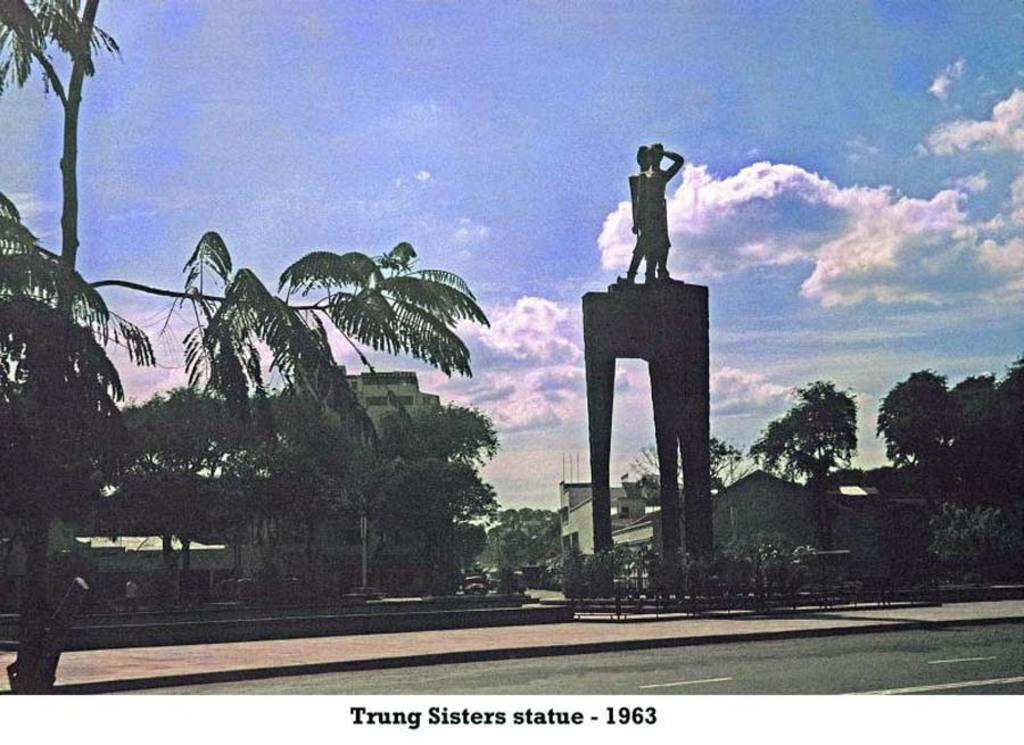What is the color scheme of the image? The image is in black and white. What is the main subject in the image? There is a statue in the image. What type of natural elements can be seen in the image? There are trees in the image. What type of man-made structures are visible in the image? There are buildings in the image. What is the weather condition in the image? The sky is cloudy in the image. Can you tell me how many wrens are perched on the statue in the image? There are no wrens present in the image; it features a statue, trees, buildings, and a cloudy sky. How does the statue show respect to the buildings in the image? The statue does not show respect to the buildings in the image, as it is a static object and cannot display emotions or actions. 